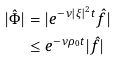Convert formula to latex. <formula><loc_0><loc_0><loc_500><loc_500>| \hat { \Phi } | & = | e ^ { - \nu | \xi | ^ { 2 } t } \hat { f } | \\ & \leq e ^ { - \nu \rho _ { 0 } t } | \hat { f } |</formula> 